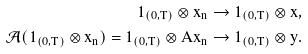<formula> <loc_0><loc_0><loc_500><loc_500>\mathbf 1 _ { ( 0 , T ) } \otimes x _ { n } \to \mathbf 1 _ { ( 0 , T ) } \otimes x , \\ \mathcal { A } ( \mathbf 1 _ { ( 0 , T ) } \otimes x _ { n } ) = \mathbf 1 _ { ( 0 , T ) } \otimes A x _ { n } \to \mathbf 1 _ { ( 0 , T ) } \otimes y .</formula> 